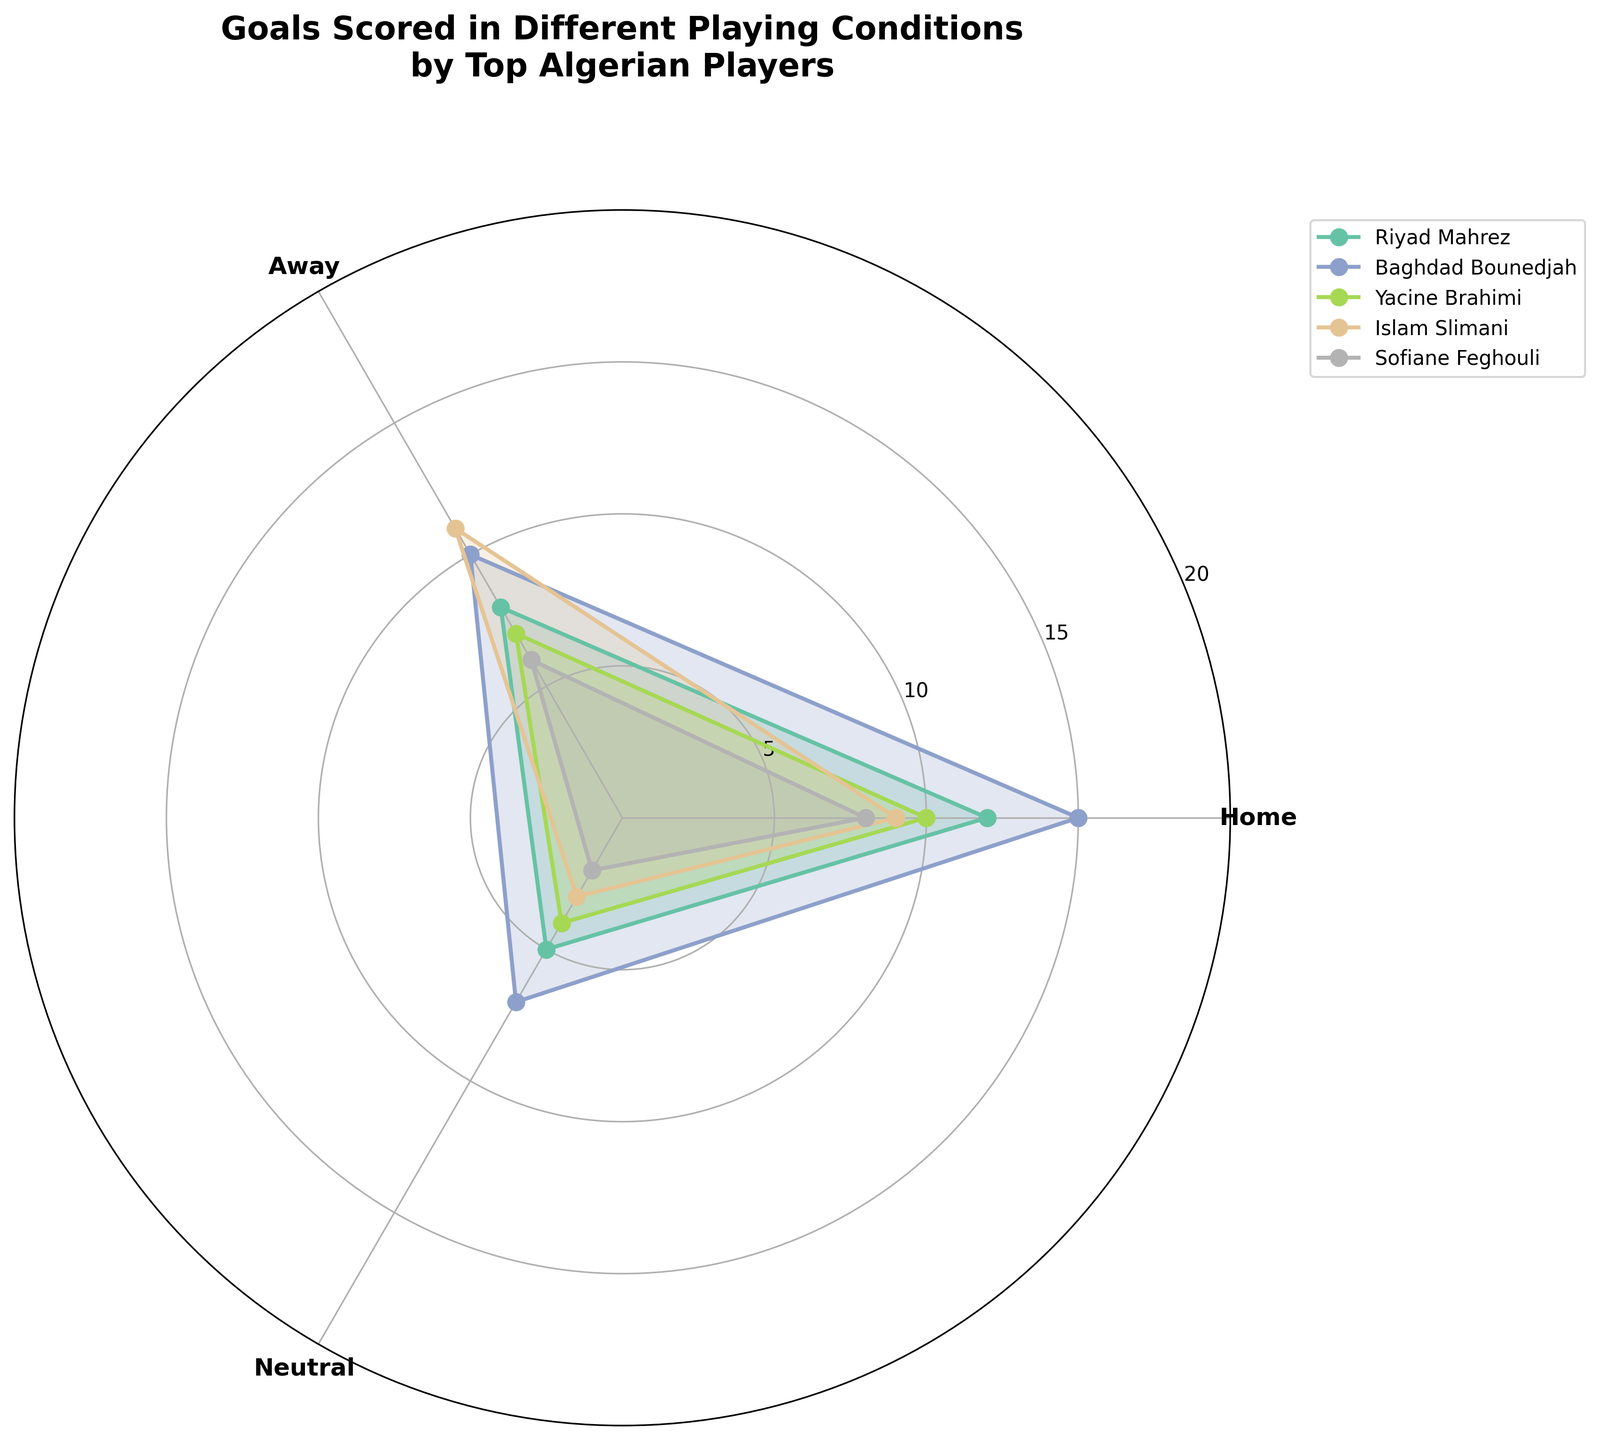What is the title of the chart? The title is located at the very top of the polar area chart, clearly labeled to describe what the figure represents.
Answer: Goals Scored in Different Playing Conditions by Top Algerian Players Which player scored the most goals at home? To determine this, look at the "Home" section of the polar chart and identify the player with the highest point in that section. Baghdad Bounedjah has the largest value (15 goals).
Answer: Baghdad Bounedjah How many goals did Riyad Mahrez score in neutral conditions? Locate Riyad Mahrez's segment in the "Neutral" area on the polar chart. The value at that point represents the number of goals he scored in neutral conditions. It is 5 goals.
Answer: 5 goals Which player has the smallest difference between home and away goals? Calculate the difference between home and away goals for each player by visually inspecting the chart. For Mahrez (4), Bounedjah (5), Brahimi (3), Slimani (2), Feghouli (2), both Slimani and Feghouli have the smallest difference.
Answer: Islam Slimani and Sofiane Feghouli How many goals did Yacine Brahimi score in total? Add Yacine Brahimi's goals scored in each playing condition: Home (10), Away (7), and Neutral (4). Summing these gives 21 goals.
Answer: 21 goals Who scored more goals in away conditions, Riyad Mahrez or Islam Slimani? Look at the "Away" segment for both Riyad Mahrez and Islam Slimani. Riyad Mahrez scored 8 goals and Islam Slimani scored 11 goals.
Answer: Islam Slimani Which player has the widest spread in goals scored across different conditions? To find the widest spread, compute the difference between the highest and lowest values for each player. For Mahrez (12-5=7), Bounedjah (15-7=8), Brahimi (10-4=6), Slimani (11-3=8), Feghouli (8-2=6). Bounedjah and Slimani both have the widest spread (8 goals).
Answer: Baghdad Bounedjah and Islam Slimani Arrange the players in ascending order of the total goals scored. Calculate the total goals for each player: Mahrez (25), Bounedjah (32), Brahimi (21), Slimani (23), Feghouli (16). Then arrange them in ascending order: Feghouli, Brahimi, Slimani, Mahrez, Bounedjah.
Answer: Sofiane Feghouli, Yacine Brahimi, Islam Slimani, Riyad Mahrez, Baghdad Bounedjah Which playing condition appears to have the highest cumulative goals scored by all players? Sum the goals for all players in each condition: Home (54), Away (42), Neutral (21). The "Home" condition has the highest cumulative goals.
Answer: Home Which player performed more consistently across all playing conditions? Consistency can be approximated by looking for players with similar values across all conditions, indicating less variation. Yacine Brahimi’s values are relatively close (10, 7, 4), which suggests consistency.
Answer: Yacine Brahimi 